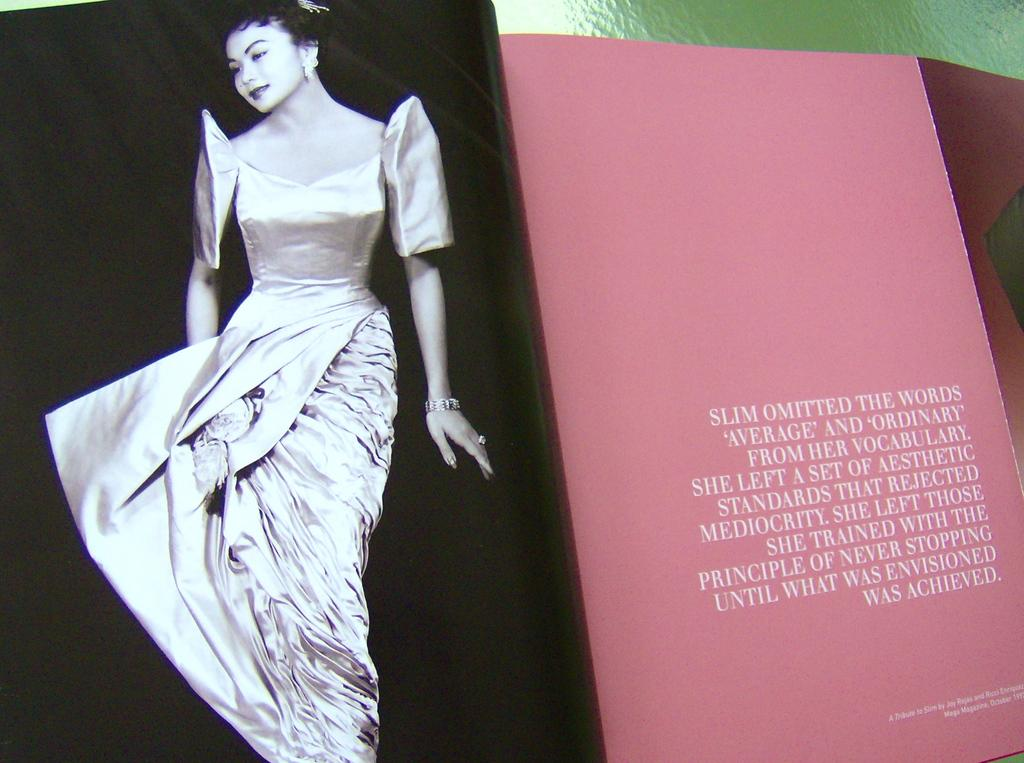<image>
Provide a brief description of the given image. An open book with a lady in a dress on one side and words that start out saying Slim Omitted The Words on it. 